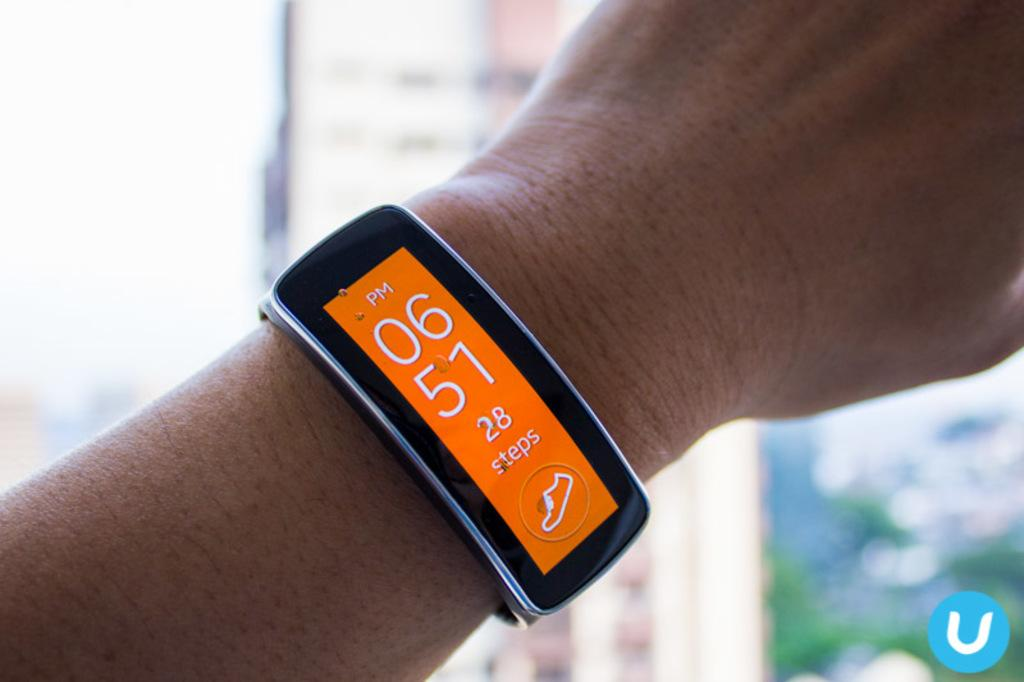<image>
Present a compact description of the photo's key features. A smart device has a bright orange screen that says 28 steps. 